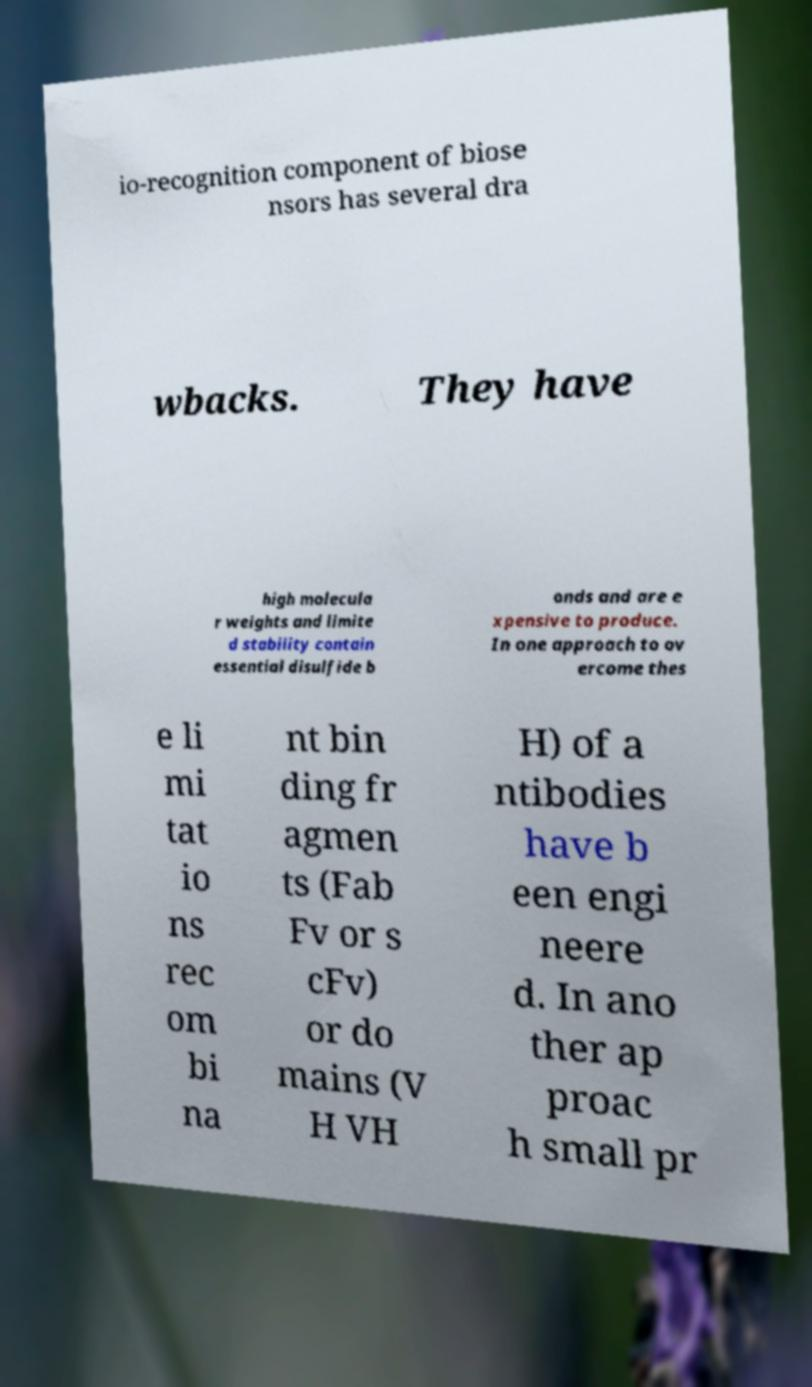Please read and relay the text visible in this image. What does it say? io-recognition component of biose nsors has several dra wbacks. They have high molecula r weights and limite d stability contain essential disulfide b onds and are e xpensive to produce. In one approach to ov ercome thes e li mi tat io ns rec om bi na nt bin ding fr agmen ts (Fab Fv or s cFv) or do mains (V H VH H) of a ntibodies have b een engi neere d. In ano ther ap proac h small pr 